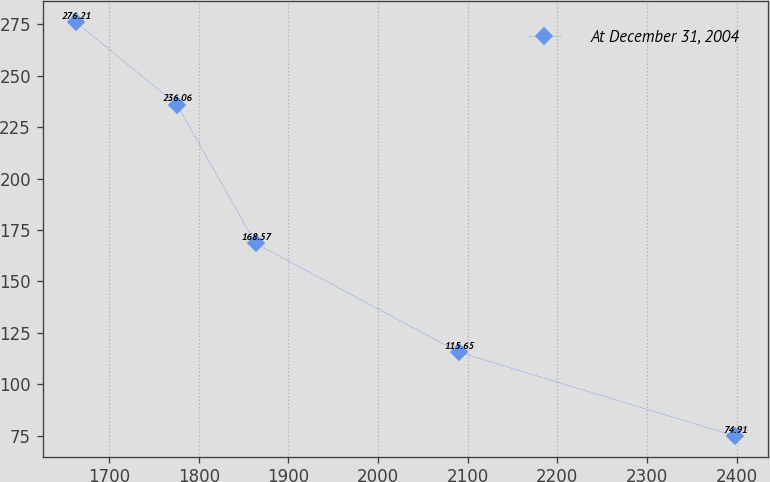Convert chart to OTSL. <chart><loc_0><loc_0><loc_500><loc_500><line_chart><ecel><fcel>At December 31, 2004<nl><fcel>1662.58<fcel>276.21<nl><fcel>1775.52<fcel>236.06<nl><fcel>1863.28<fcel>168.57<nl><fcel>2089.77<fcel>115.65<nl><fcel>2397.89<fcel>74.91<nl></chart> 